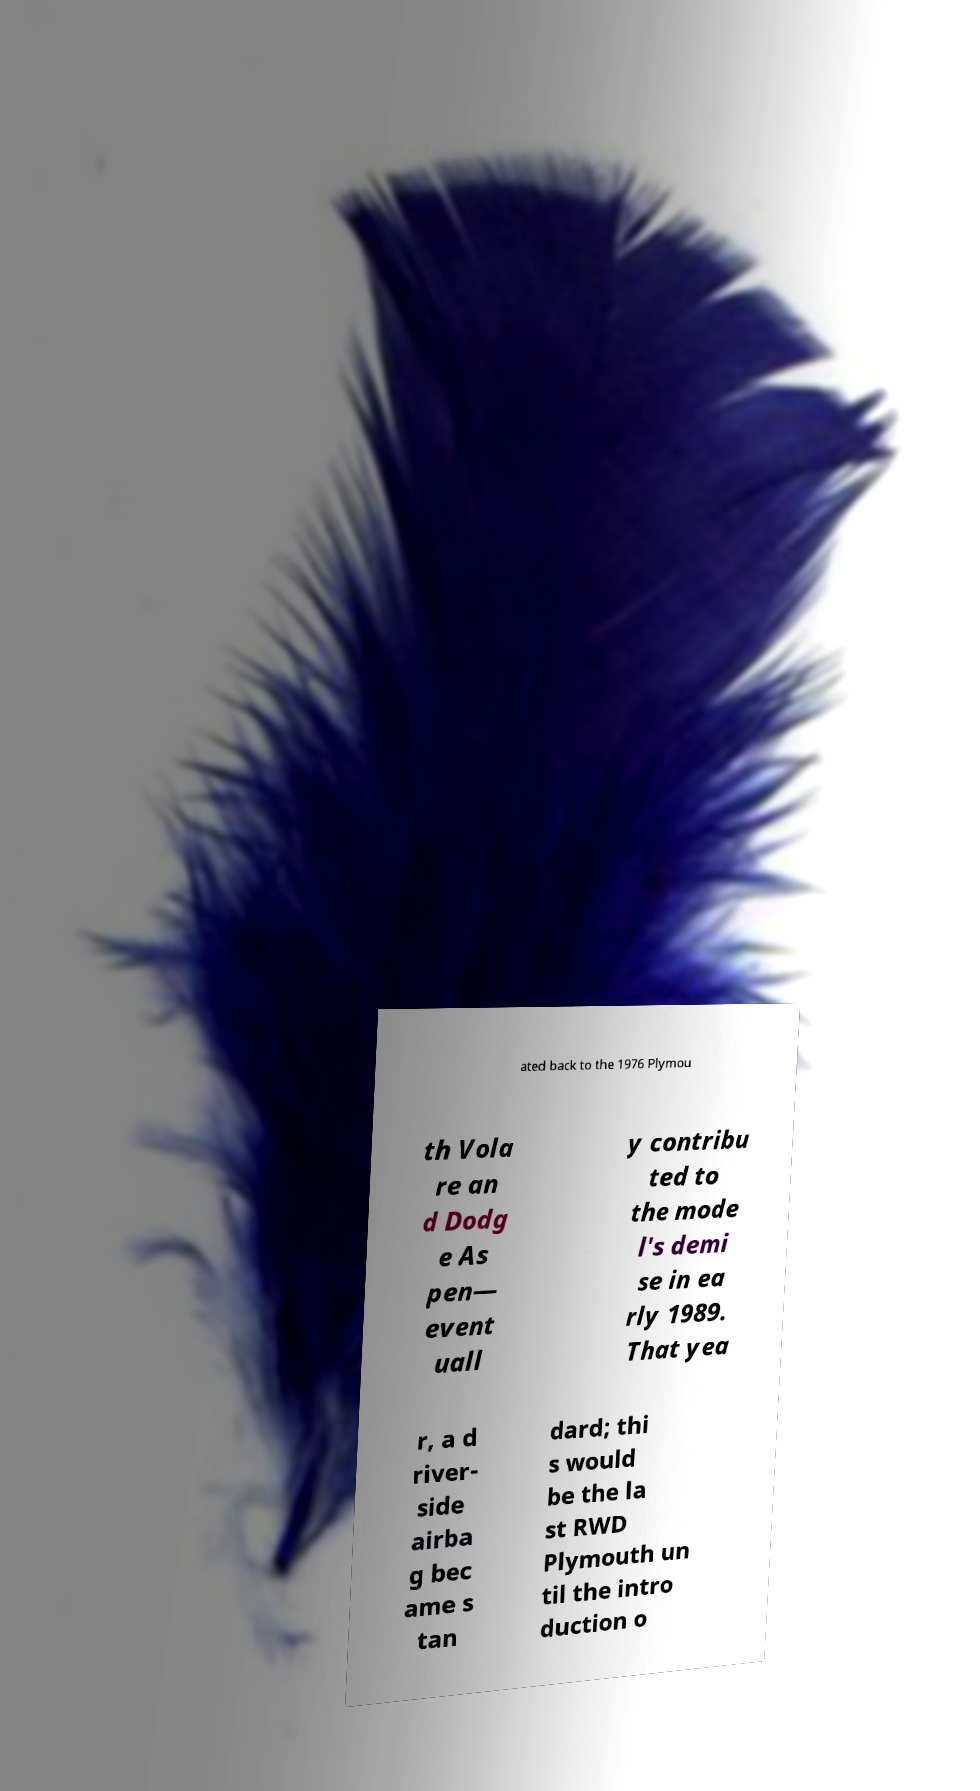Could you assist in decoding the text presented in this image and type it out clearly? ated back to the 1976 Plymou th Vola re an d Dodg e As pen— event uall y contribu ted to the mode l's demi se in ea rly 1989. That yea r, a d river- side airba g bec ame s tan dard; thi s would be the la st RWD Plymouth un til the intro duction o 